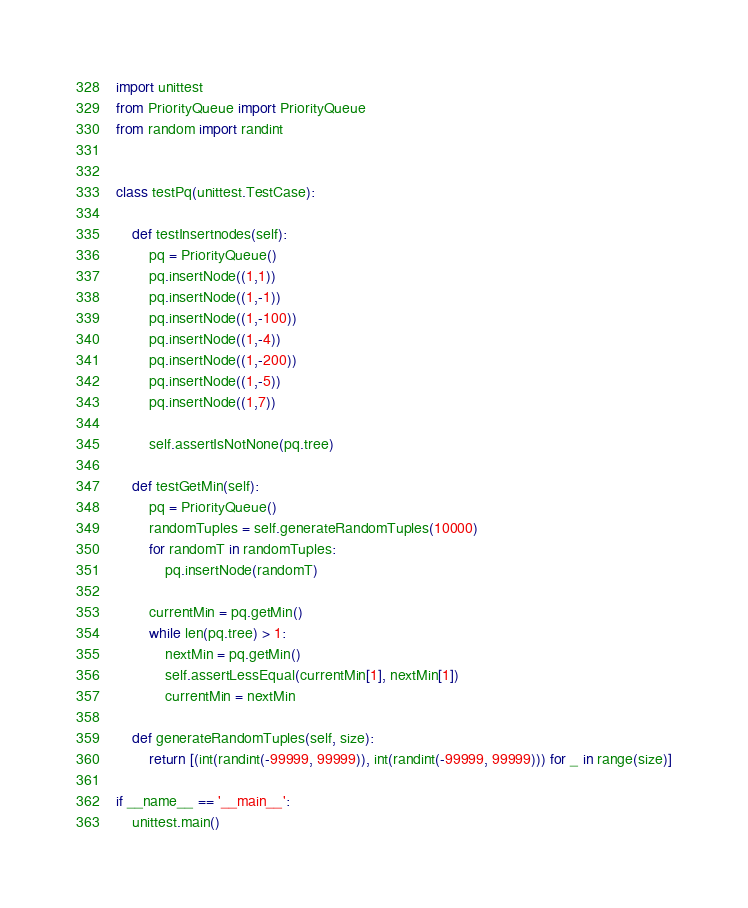Convert code to text. <code><loc_0><loc_0><loc_500><loc_500><_Python_>import unittest
from PriorityQueue import PriorityQueue
from random import randint


class testPq(unittest.TestCase):

    def testInsertnodes(self):
        pq = PriorityQueue()
        pq.insertNode((1,1))
        pq.insertNode((1,-1))
        pq.insertNode((1,-100))
        pq.insertNode((1,-4))
        pq.insertNode((1,-200))
        pq.insertNode((1,-5))
        pq.insertNode((1,7))

        self.assertIsNotNone(pq.tree)

    def testGetMin(self):
        pq = PriorityQueue()
        randomTuples = self.generateRandomTuples(10000)
        for randomT in randomTuples:
            pq.insertNode(randomT)
        
        currentMin = pq.getMin()
        while len(pq.tree) > 1:
            nextMin = pq.getMin()
            self.assertLessEqual(currentMin[1], nextMin[1])
            currentMin = nextMin

    def generateRandomTuples(self, size):
        return [(int(randint(-99999, 99999)), int(randint(-99999, 99999))) for _ in range(size)]

if __name__ == '__main__':
    unittest.main()
</code> 